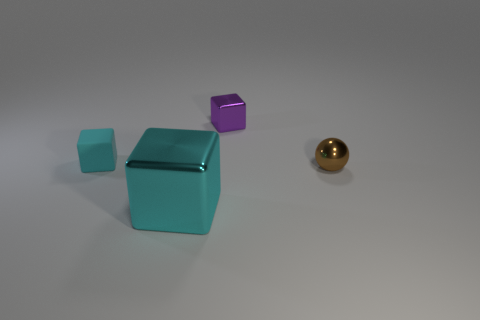How would you interpret the arrangement of these objects? The arrangement of the objects can evoke different interpretations. One might view it as a simple display of geometric shapes with varying sizes and colors, suggesting an underlying theme of diversity or contrast. Alternatively, it could be seen as a metaphorical representation of order and balance, with each object spaced in a way that creates a harmonious composition. Does this arrangement suggest any particular narrative or story? While the image is quite abstract, one could imagine a narrative where the objects symbolize entities or characters. For example, the large teal box could represent a central figure or a leader, the smaller teal piece its loyal companion, and the small purple cube a distant observer or an outsider, with the golden ball as a precious object or goal they are all positioned around. 